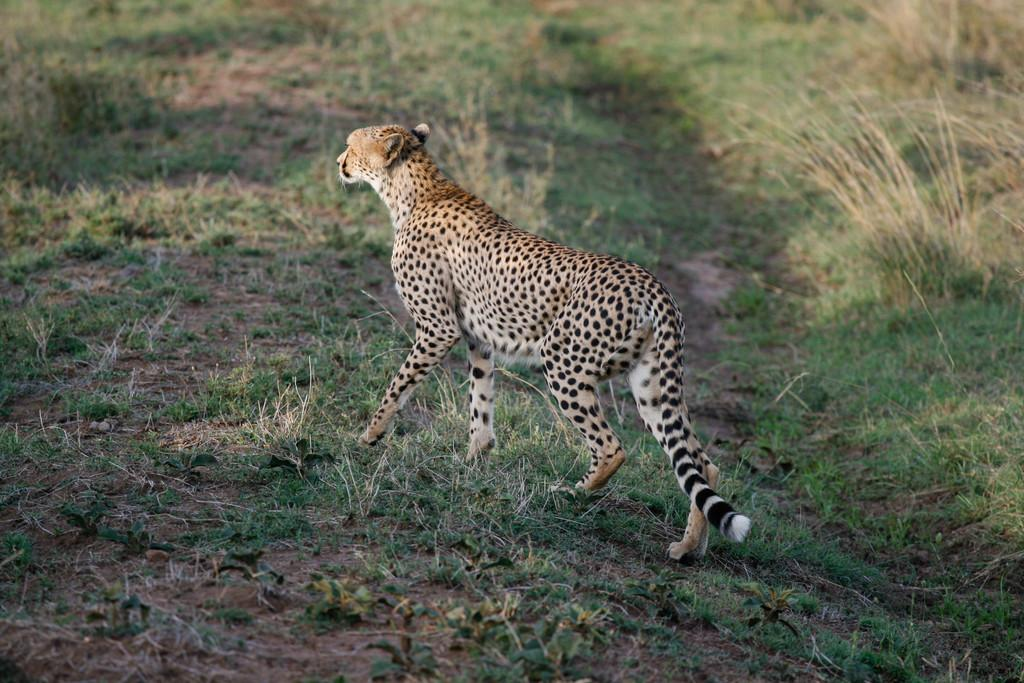What animal is standing in the image? There is a cheetah standing in the image. What type of environment is visible in the background of the image? There is grass in the background of the image. What type of car is being operated by the cheetah in the image? There is no car present in the image, and the cheetah is not operating anything. 